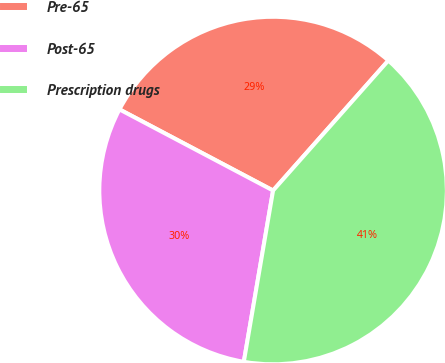Convert chart to OTSL. <chart><loc_0><loc_0><loc_500><loc_500><pie_chart><fcel>Pre-65<fcel>Post-65<fcel>Prescription drugs<nl><fcel>28.81%<fcel>30.04%<fcel>41.15%<nl></chart> 